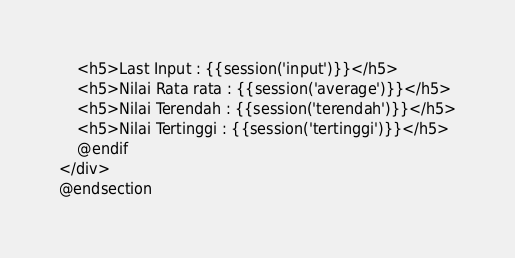<code> <loc_0><loc_0><loc_500><loc_500><_PHP_>    <h5>Last Input : {{session('input')}}</h5>
    <h5>Nilai Rata rata : {{session('average')}}</h5>
    <h5>Nilai Terendah : {{session('terendah')}}</h5>
    <h5>Nilai Tertinggi : {{session('tertinggi')}}</h5>
    @endif
</div>
@endsection</code> 